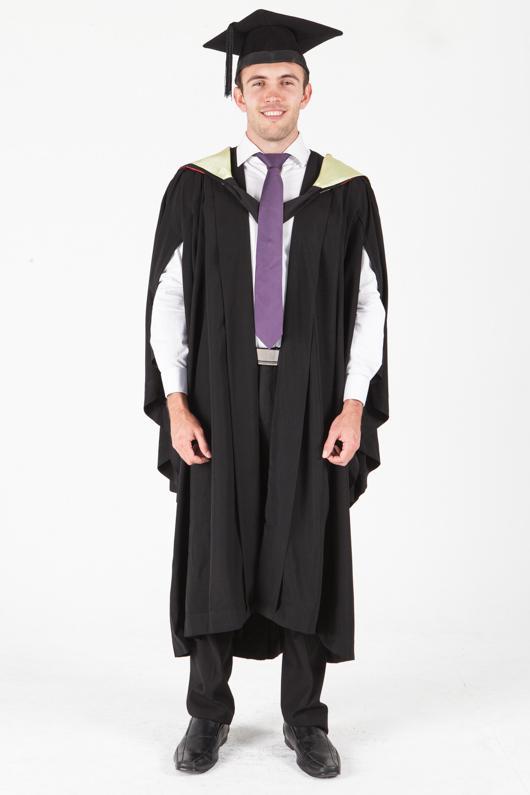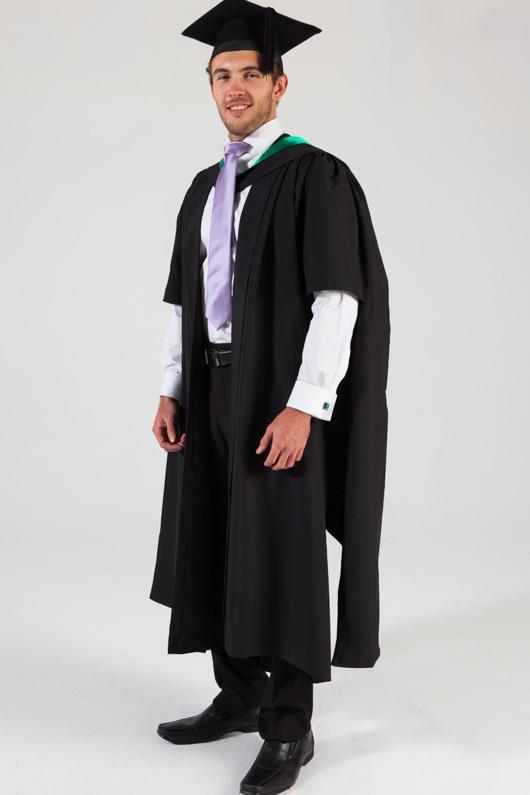The first image is the image on the left, the second image is the image on the right. Examine the images to the left and right. Is the description "An image shows front and rear views of a graduation model." accurate? Answer yes or no. No. The first image is the image on the left, the second image is the image on the right. For the images displayed, is the sentence "There are exactly two people in the image on the right." factually correct? Answer yes or no. No. 